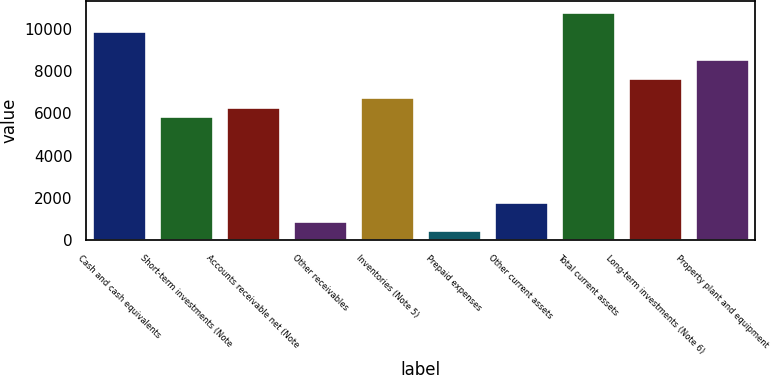<chart> <loc_0><loc_0><loc_500><loc_500><bar_chart><fcel>Cash and cash equivalents<fcel>Short-term investments (Note<fcel>Accounts receivable net (Note<fcel>Other receivables<fcel>Inventories (Note 5)<fcel>Prepaid expenses<fcel>Other current assets<fcel>Total current assets<fcel>Long-term investments (Note 6)<fcel>Property plant and equipment<nl><fcel>9884.08<fcel>5853.52<fcel>6301.36<fcel>927.28<fcel>6749.2<fcel>479.44<fcel>1822.96<fcel>10779.8<fcel>7644.88<fcel>8540.56<nl></chart> 